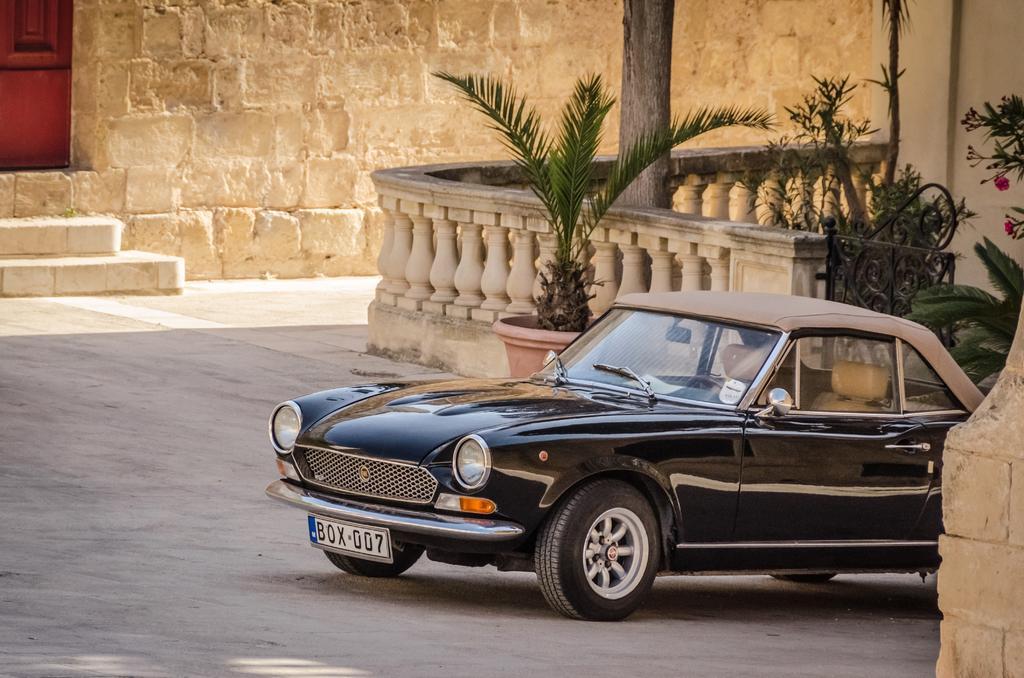Can you describe this image briefly? In the image we can see a car, these are the headlights and number plate of the vehicle. This is a road, stairs, fence, plant pot, pole and a wall. 